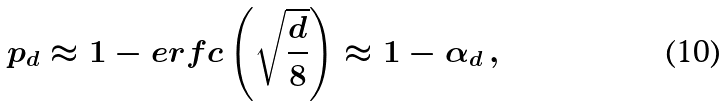<formula> <loc_0><loc_0><loc_500><loc_500>p _ { d } \approx 1 - e r f c \left ( \sqrt { \frac { d } { 8 } } \right ) \approx 1 - \alpha _ { d } \, ,</formula> 